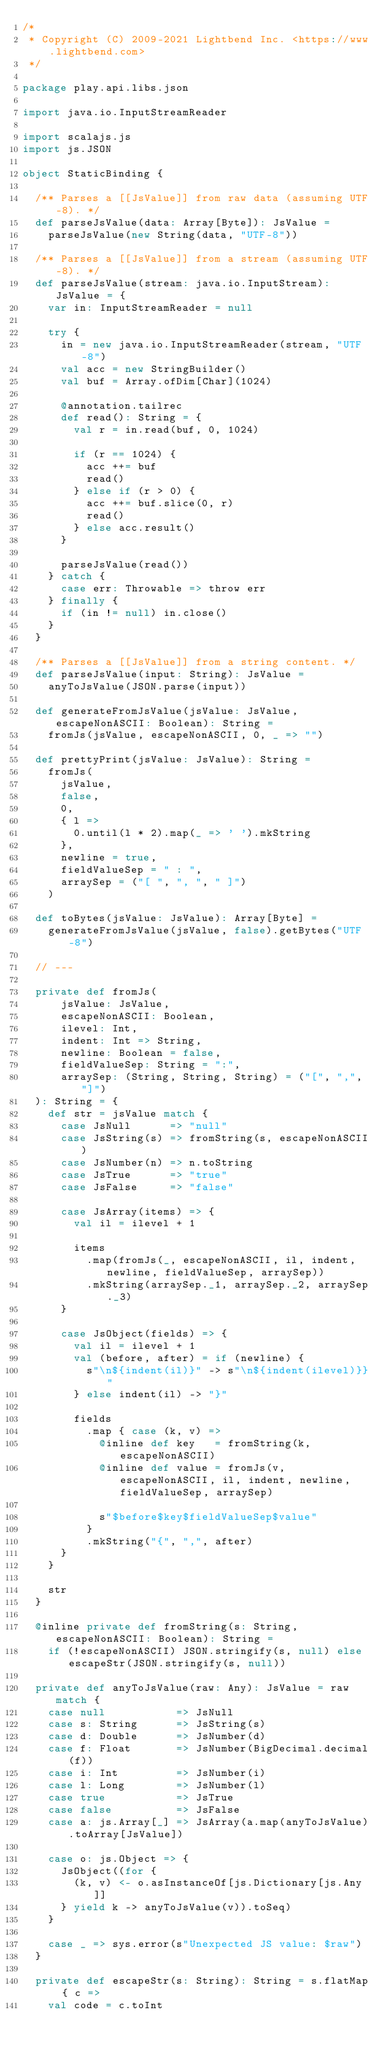<code> <loc_0><loc_0><loc_500><loc_500><_Scala_>/*
 * Copyright (C) 2009-2021 Lightbend Inc. <https://www.lightbend.com>
 */

package play.api.libs.json

import java.io.InputStreamReader

import scalajs.js
import js.JSON

object StaticBinding {

  /** Parses a [[JsValue]] from raw data (assuming UTF-8). */
  def parseJsValue(data: Array[Byte]): JsValue =
    parseJsValue(new String(data, "UTF-8"))

  /** Parses a [[JsValue]] from a stream (assuming UTF-8). */
  def parseJsValue(stream: java.io.InputStream): JsValue = {
    var in: InputStreamReader = null

    try {
      in = new java.io.InputStreamReader(stream, "UTF-8")
      val acc = new StringBuilder()
      val buf = Array.ofDim[Char](1024)

      @annotation.tailrec
      def read(): String = {
        val r = in.read(buf, 0, 1024)

        if (r == 1024) {
          acc ++= buf
          read()
        } else if (r > 0) {
          acc ++= buf.slice(0, r)
          read()
        } else acc.result()
      }

      parseJsValue(read())
    } catch {
      case err: Throwable => throw err
    } finally {
      if (in != null) in.close()
    }
  }

  /** Parses a [[JsValue]] from a string content. */
  def parseJsValue(input: String): JsValue =
    anyToJsValue(JSON.parse(input))

  def generateFromJsValue(jsValue: JsValue, escapeNonASCII: Boolean): String =
    fromJs(jsValue, escapeNonASCII, 0, _ => "")

  def prettyPrint(jsValue: JsValue): String =
    fromJs(
      jsValue,
      false,
      0,
      { l =>
        0.until(l * 2).map(_ => ' ').mkString
      },
      newline = true,
      fieldValueSep = " : ",
      arraySep = ("[ ", ", ", " ]")
    )

  def toBytes(jsValue: JsValue): Array[Byte] =
    generateFromJsValue(jsValue, false).getBytes("UTF-8")

  // ---

  private def fromJs(
      jsValue: JsValue,
      escapeNonASCII: Boolean,
      ilevel: Int,
      indent: Int => String,
      newline: Boolean = false,
      fieldValueSep: String = ":",
      arraySep: (String, String, String) = ("[", ",", "]")
  ): String = {
    def str = jsValue match {
      case JsNull      => "null"
      case JsString(s) => fromString(s, escapeNonASCII)
      case JsNumber(n) => n.toString
      case JsTrue      => "true"
      case JsFalse     => "false"

      case JsArray(items) => {
        val il = ilevel + 1

        items
          .map(fromJs(_, escapeNonASCII, il, indent, newline, fieldValueSep, arraySep))
          .mkString(arraySep._1, arraySep._2, arraySep._3)
      }

      case JsObject(fields) => {
        val il = ilevel + 1
        val (before, after) = if (newline) {
          s"\n${indent(il)}" -> s"\n${indent(ilevel)}}"
        } else indent(il) -> "}"

        fields
          .map { case (k, v) =>
            @inline def key   = fromString(k, escapeNonASCII)
            @inline def value = fromJs(v, escapeNonASCII, il, indent, newline, fieldValueSep, arraySep)

            s"$before$key$fieldValueSep$value"
          }
          .mkString("{", ",", after)
      }
    }

    str
  }

  @inline private def fromString(s: String, escapeNonASCII: Boolean): String =
    if (!escapeNonASCII) JSON.stringify(s, null) else escapeStr(JSON.stringify(s, null))

  private def anyToJsValue(raw: Any): JsValue = raw match {
    case null           => JsNull
    case s: String      => JsString(s)
    case d: Double      => JsNumber(d)
    case f: Float       => JsNumber(BigDecimal.decimal(f))
    case i: Int         => JsNumber(i)
    case l: Long        => JsNumber(l)
    case true           => JsTrue
    case false          => JsFalse
    case a: js.Array[_] => JsArray(a.map(anyToJsValue).toArray[JsValue])

    case o: js.Object => {
      JsObject((for {
        (k, v) <- o.asInstanceOf[js.Dictionary[js.Any]]
      } yield k -> anyToJsValue(v)).toSeq)
    }

    case _ => sys.error(s"Unexpected JS value: $raw")
  }

  private def escapeStr(s: String): String = s.flatMap { c =>
    val code = c.toInt
</code> 